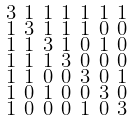Convert formula to latex. <formula><loc_0><loc_0><loc_500><loc_500>\begin{smallmatrix} 3 & 1 & 1 & 1 & 1 & 1 & 1 \\ 1 & 3 & 1 & 1 & 1 & 0 & 0 \\ 1 & 1 & 3 & 1 & 0 & 1 & 0 \\ 1 & 1 & 1 & 3 & 0 & 0 & 0 \\ 1 & 1 & 0 & 0 & 3 & 0 & 1 \\ 1 & 0 & 1 & 0 & 0 & 3 & 0 \\ 1 & 0 & 0 & 0 & 1 & 0 & 3 \end{smallmatrix}</formula> 